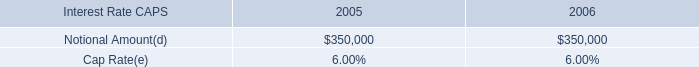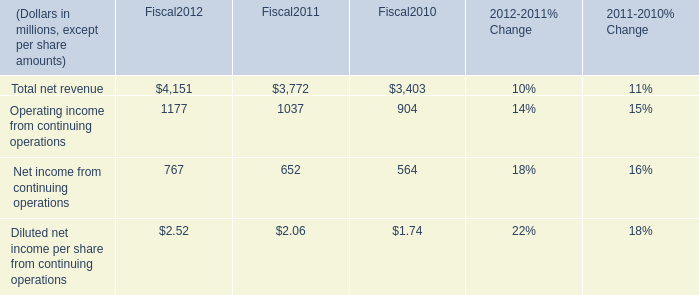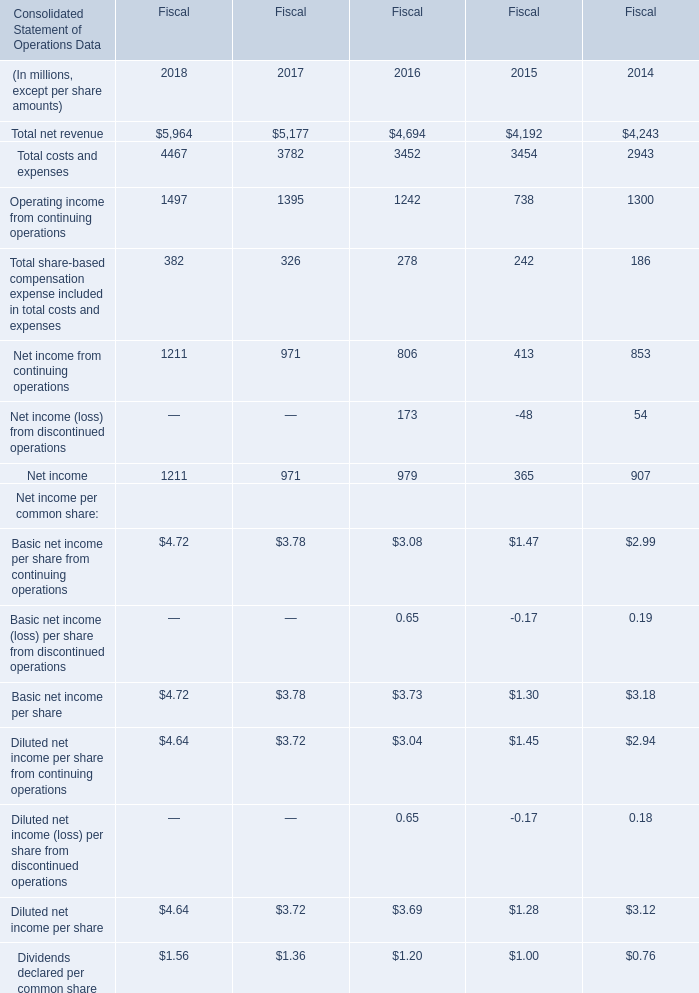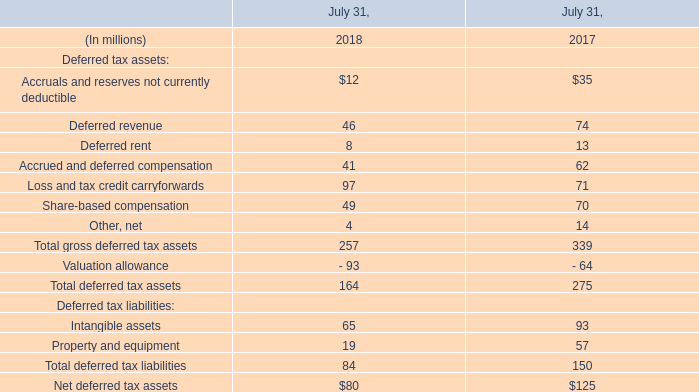What is the average amount of Operating income from continuing operations of Fiscal 2016, and Operating income from continuing operations of Fiscal2011 ? 
Computations: ((1242.0 + 1037.0) / 2)
Answer: 1139.5. 